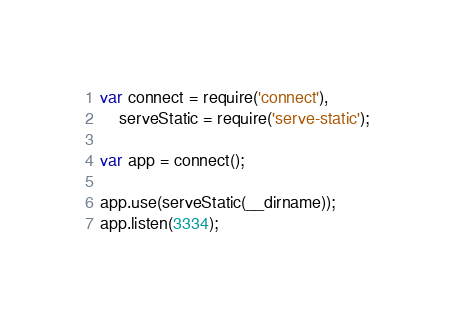<code> <loc_0><loc_0><loc_500><loc_500><_JavaScript_>var connect = require('connect'),
    serveStatic = require('serve-static');

var app = connect();

app.use(serveStatic(__dirname));
app.listen(3334);
</code> 